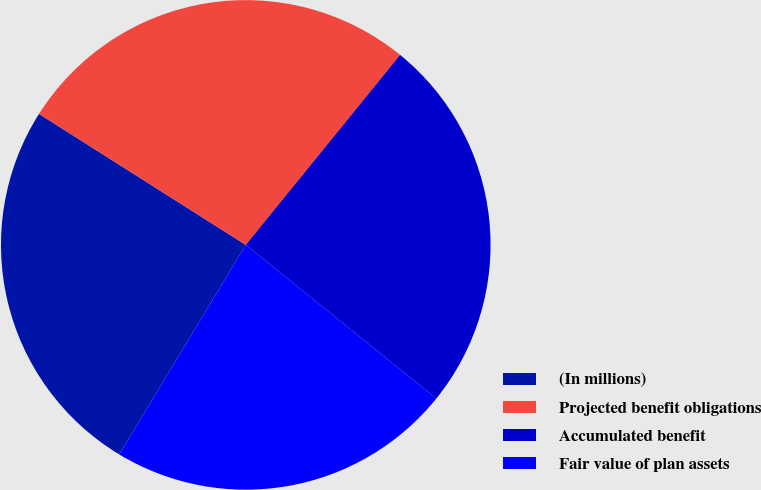Convert chart. <chart><loc_0><loc_0><loc_500><loc_500><pie_chart><fcel>(In millions)<fcel>Projected benefit obligations<fcel>Accumulated benefit<fcel>Fair value of plan assets<nl><fcel>25.34%<fcel>26.87%<fcel>24.94%<fcel>22.85%<nl></chart> 